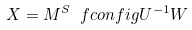Convert formula to latex. <formula><loc_0><loc_0><loc_500><loc_500>X = M ^ { S } \ f c o n f i g { U } ^ { - 1 } W</formula> 